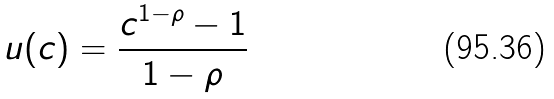<formula> <loc_0><loc_0><loc_500><loc_500>u ( c ) = \frac { c ^ { 1 - \rho } - 1 } { 1 - \rho }</formula> 